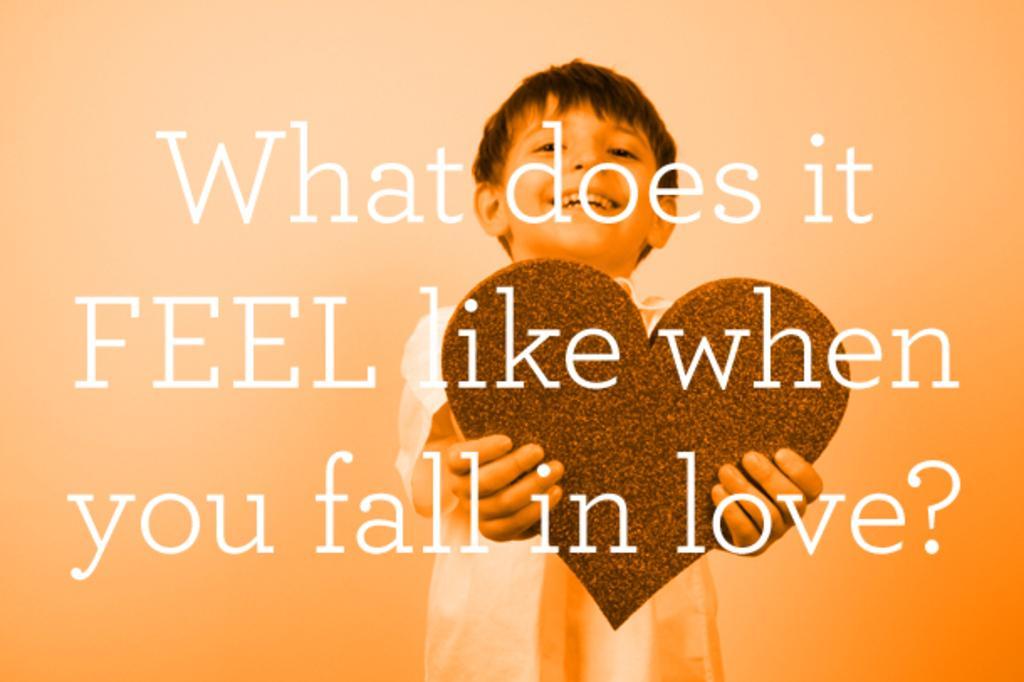In one or two sentences, can you explain what this image depicts? In this picture I can see a boy standing and smiling by holding an object, and there is a quotation on the image. 